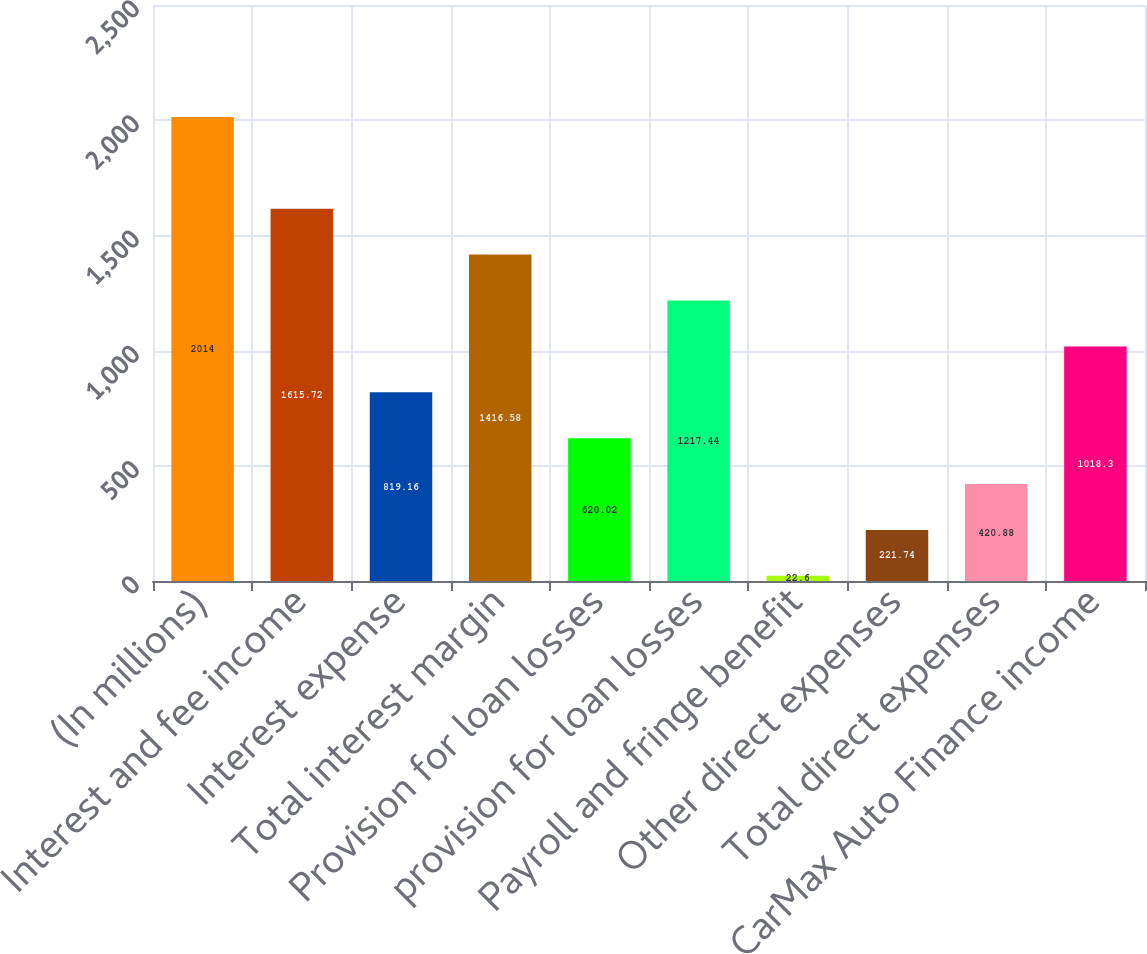Convert chart. <chart><loc_0><loc_0><loc_500><loc_500><bar_chart><fcel>(In millions)<fcel>Interest and fee income<fcel>Interest expense<fcel>Total interest margin<fcel>Provision for loan losses<fcel>provision for loan losses<fcel>Payroll and fringe benefit<fcel>Other direct expenses<fcel>Total direct expenses<fcel>CarMax Auto Finance income<nl><fcel>2014<fcel>1615.72<fcel>819.16<fcel>1416.58<fcel>620.02<fcel>1217.44<fcel>22.6<fcel>221.74<fcel>420.88<fcel>1018.3<nl></chart> 